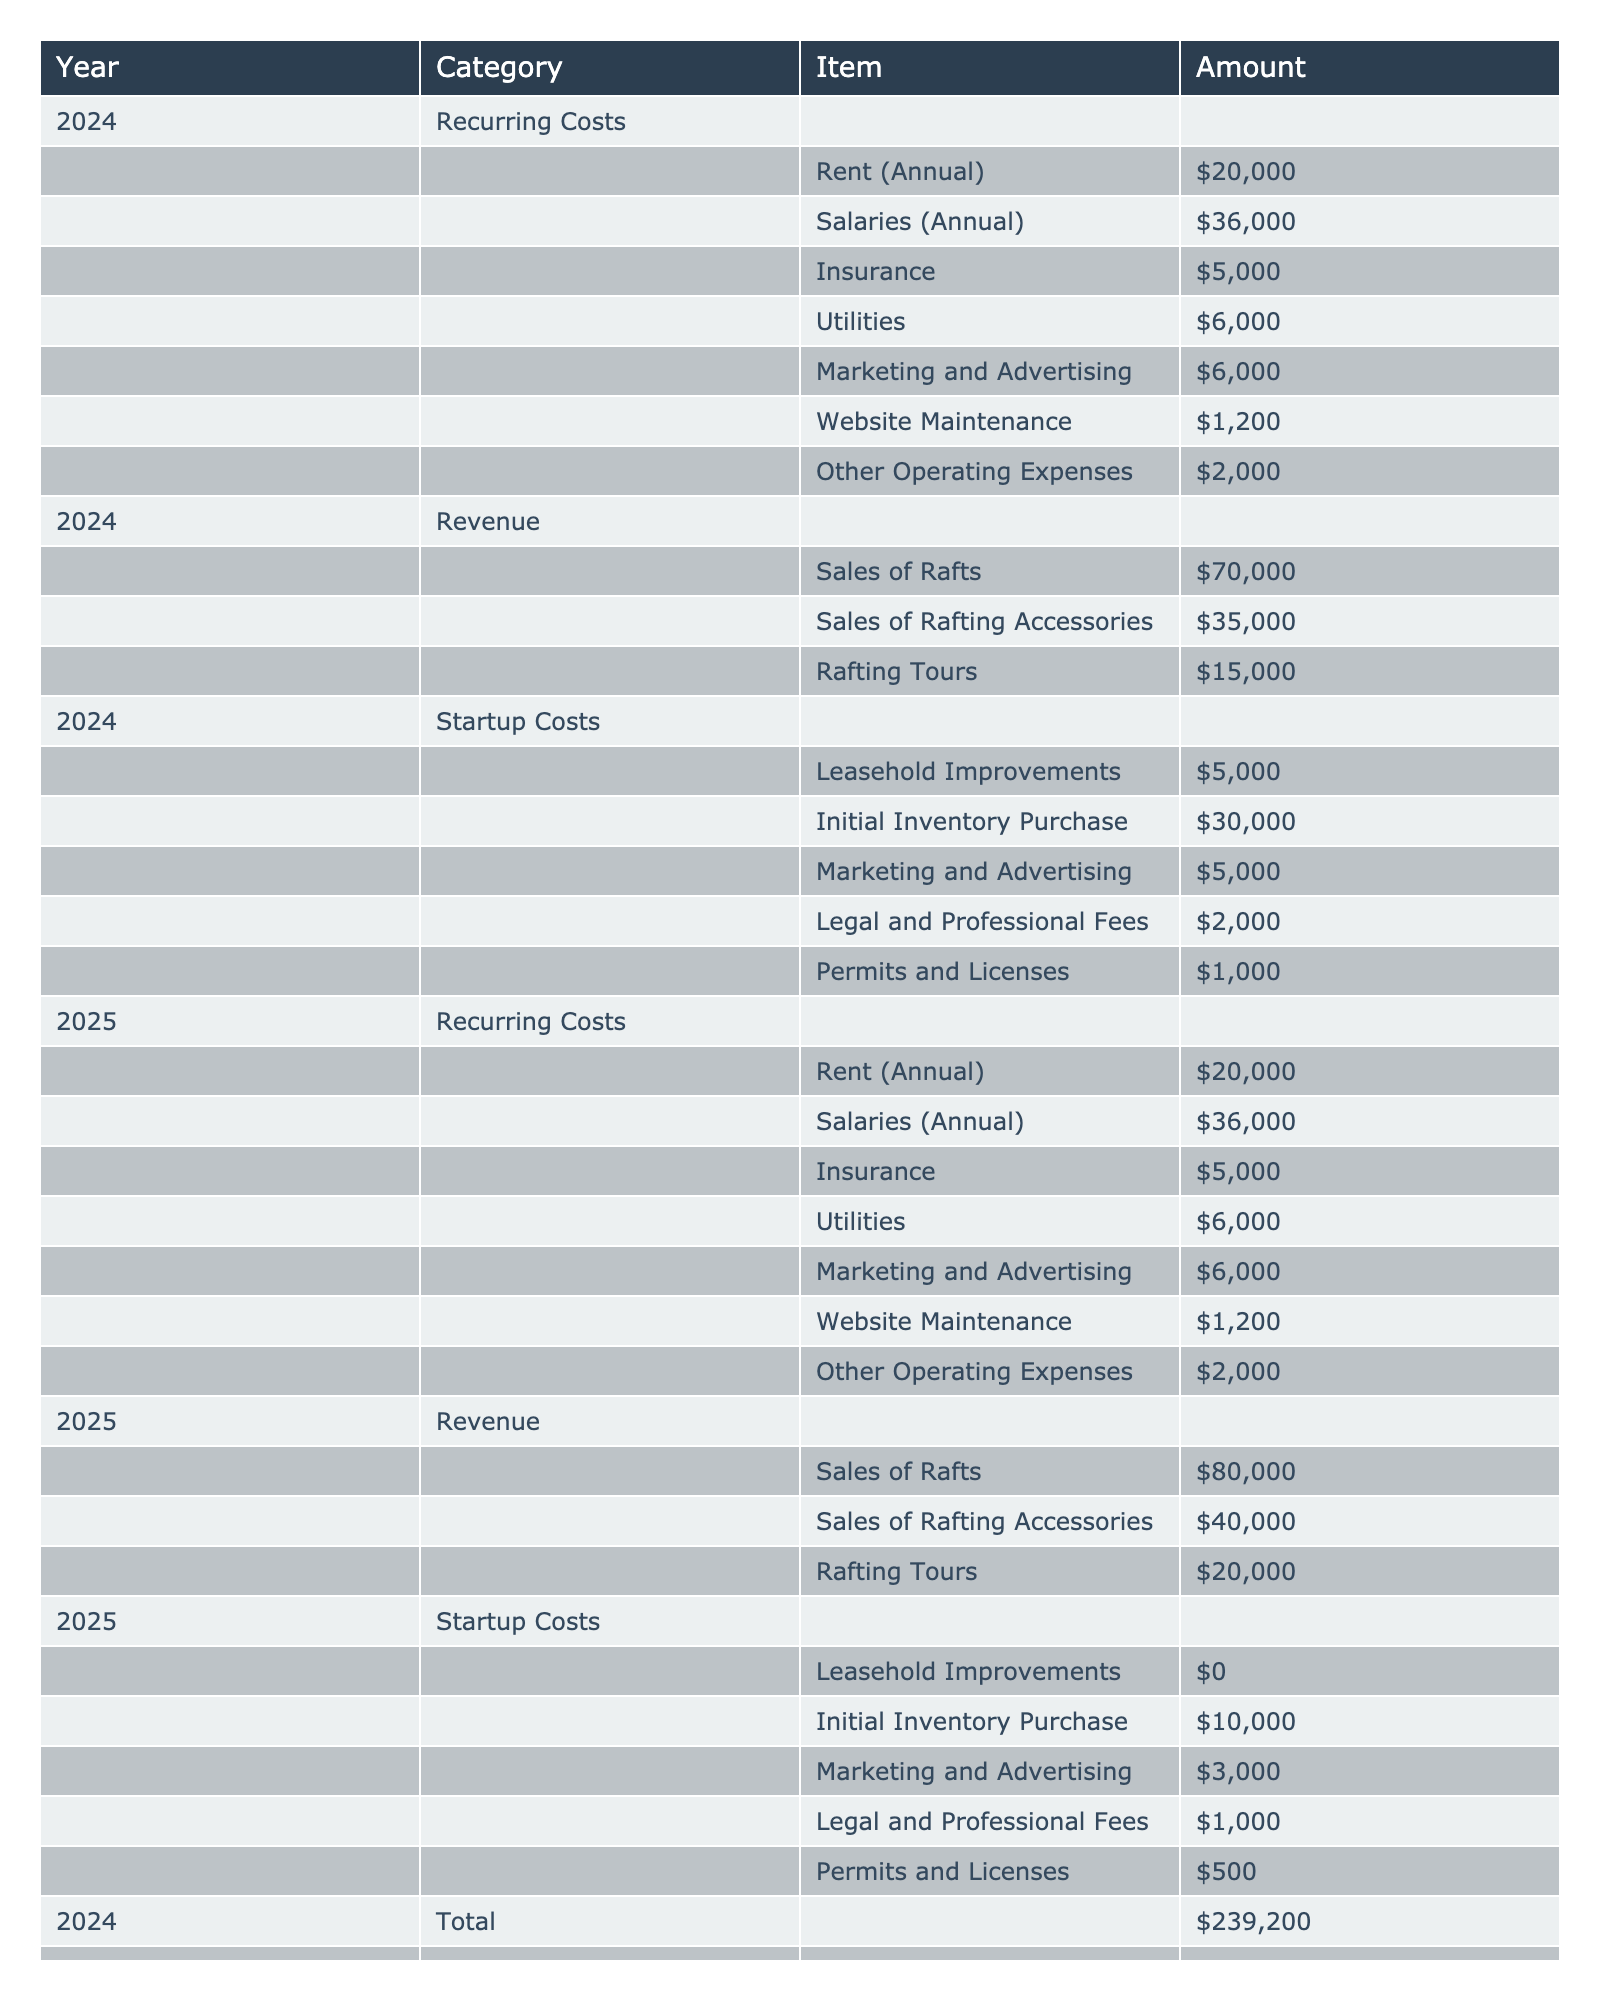What is the total amount of startup costs for 2024? To find the total startup costs for 2024, we add all the amounts listed under the Startup Costs category for that year: 5000 (Leasehold Improvements) + 30000 (Initial Inventory Purchase) + 5000 (Marketing and Advertising) + 2000 (Legal and Professional Fees) + 1000 (Permits and Licenses) = 41000.
Answer: 41000 How much did the revenue from sales of rafts increase from 2024 to 2025? The revenue from sales of rafts in 2024 is 70000, and in 2025 it is 80000. To calculate the increase, we subtract the 2024 value from the 2025 value: 80000 - 70000 = 10000.
Answer: 10000 What were the total recurring costs for 2025? To find the total recurring costs for 2025, we add the amounts listed under the Recurring Costs category: 20000 (Rent) + 36000 (Salaries) + 5000 (Insurance) + 6000 (Utilities) + 6000 (Marketing and Advertising) + 1200 (Website Maintenance) + 2000 (Other Operating Expenses) = 80000.
Answer: 80000 Is the total revenue for 2024 greater than the total of startup costs for that year? The total revenue for 2024 is obtained by adding the revenue components: 70000 (Sales of Rafts) + 35000 (Sales of Rafting Accessories) + 15000 (Rafting Tours) = 120000. The total startup costs for 2024 is 41000. Since 120000 is greater than 41000, the answer is yes.
Answer: Yes What is the difference between the total revenue in 2025 and the total recurring costs in that year? First, we calculate the total revenue for 2025: 80000 (Sales of Rafts) + 40000 (Sales of Rafting Accessories) + 20000 (Rafting Tours) = 140000. We already computed the total recurring costs for 2025 as 80000. Thus, the difference is: 140000 - 80000 = 60000.
Answer: 60000 